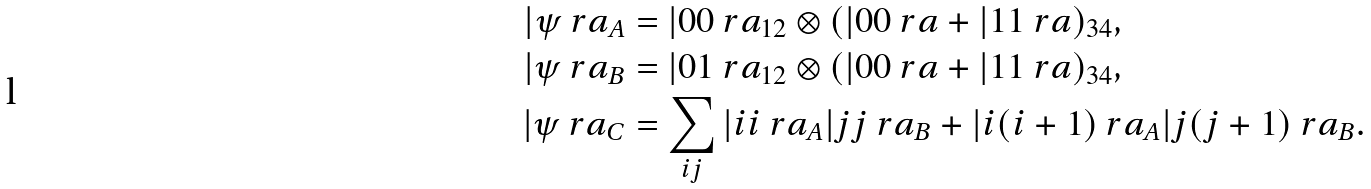Convert formula to latex. <formula><loc_0><loc_0><loc_500><loc_500>| \psi \ r a _ { A } & = | 0 0 \ r a _ { 1 2 } \otimes ( | 0 0 \ r a + | 1 1 \ r a ) _ { 3 4 } , \\ | \psi \ r a _ { B } & = | 0 1 \ r a _ { 1 2 } \otimes ( | 0 0 \ r a + | 1 1 \ r a ) _ { 3 4 } , \\ | \psi \ r a _ { C } & = \sum _ { i j } | i i \ r a _ { A } | j j \ r a _ { B } + | i ( i + 1 ) \ r a _ { A } | j ( j + 1 ) \ r a _ { B } .</formula> 